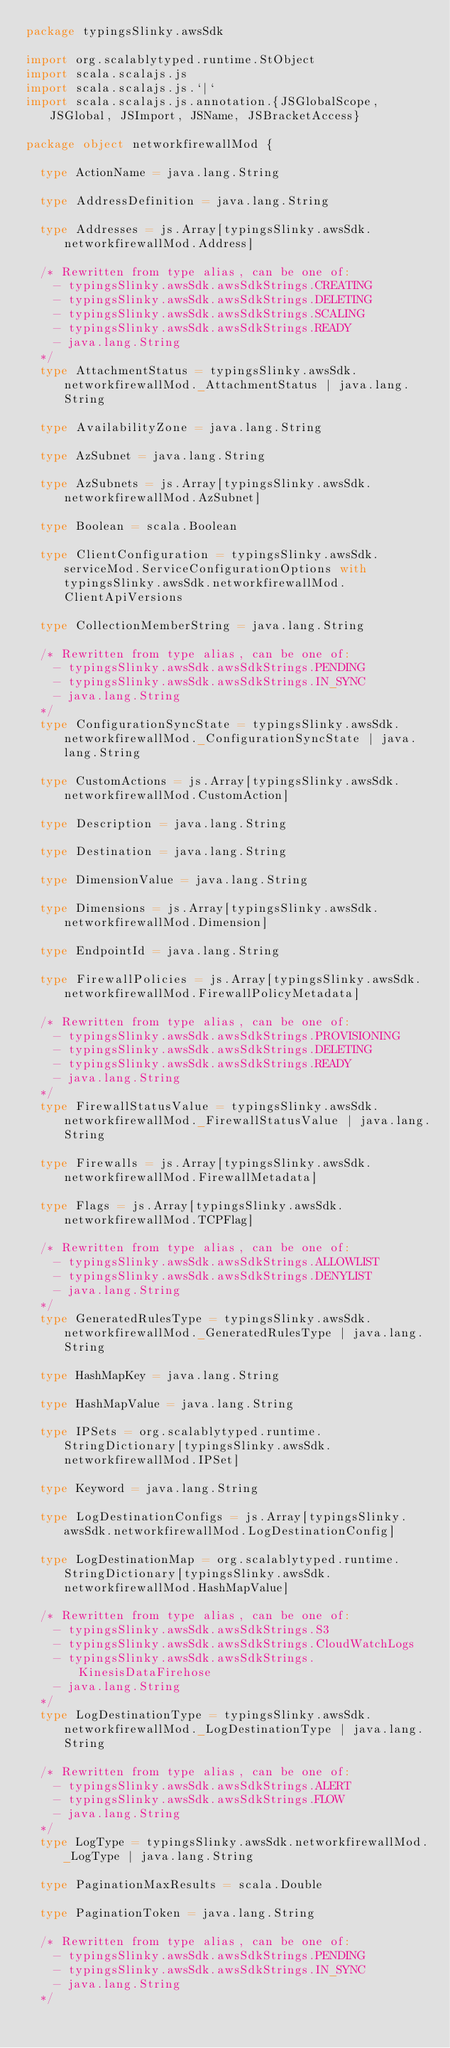Convert code to text. <code><loc_0><loc_0><loc_500><loc_500><_Scala_>package typingsSlinky.awsSdk

import org.scalablytyped.runtime.StObject
import scala.scalajs.js
import scala.scalajs.js.`|`
import scala.scalajs.js.annotation.{JSGlobalScope, JSGlobal, JSImport, JSName, JSBracketAccess}

package object networkfirewallMod {
  
  type ActionName = java.lang.String
  
  type AddressDefinition = java.lang.String
  
  type Addresses = js.Array[typingsSlinky.awsSdk.networkfirewallMod.Address]
  
  /* Rewritten from type alias, can be one of: 
    - typingsSlinky.awsSdk.awsSdkStrings.CREATING
    - typingsSlinky.awsSdk.awsSdkStrings.DELETING
    - typingsSlinky.awsSdk.awsSdkStrings.SCALING
    - typingsSlinky.awsSdk.awsSdkStrings.READY
    - java.lang.String
  */
  type AttachmentStatus = typingsSlinky.awsSdk.networkfirewallMod._AttachmentStatus | java.lang.String
  
  type AvailabilityZone = java.lang.String
  
  type AzSubnet = java.lang.String
  
  type AzSubnets = js.Array[typingsSlinky.awsSdk.networkfirewallMod.AzSubnet]
  
  type Boolean = scala.Boolean
  
  type ClientConfiguration = typingsSlinky.awsSdk.serviceMod.ServiceConfigurationOptions with typingsSlinky.awsSdk.networkfirewallMod.ClientApiVersions
  
  type CollectionMemberString = java.lang.String
  
  /* Rewritten from type alias, can be one of: 
    - typingsSlinky.awsSdk.awsSdkStrings.PENDING
    - typingsSlinky.awsSdk.awsSdkStrings.IN_SYNC
    - java.lang.String
  */
  type ConfigurationSyncState = typingsSlinky.awsSdk.networkfirewallMod._ConfigurationSyncState | java.lang.String
  
  type CustomActions = js.Array[typingsSlinky.awsSdk.networkfirewallMod.CustomAction]
  
  type Description = java.lang.String
  
  type Destination = java.lang.String
  
  type DimensionValue = java.lang.String
  
  type Dimensions = js.Array[typingsSlinky.awsSdk.networkfirewallMod.Dimension]
  
  type EndpointId = java.lang.String
  
  type FirewallPolicies = js.Array[typingsSlinky.awsSdk.networkfirewallMod.FirewallPolicyMetadata]
  
  /* Rewritten from type alias, can be one of: 
    - typingsSlinky.awsSdk.awsSdkStrings.PROVISIONING
    - typingsSlinky.awsSdk.awsSdkStrings.DELETING
    - typingsSlinky.awsSdk.awsSdkStrings.READY
    - java.lang.String
  */
  type FirewallStatusValue = typingsSlinky.awsSdk.networkfirewallMod._FirewallStatusValue | java.lang.String
  
  type Firewalls = js.Array[typingsSlinky.awsSdk.networkfirewallMod.FirewallMetadata]
  
  type Flags = js.Array[typingsSlinky.awsSdk.networkfirewallMod.TCPFlag]
  
  /* Rewritten from type alias, can be one of: 
    - typingsSlinky.awsSdk.awsSdkStrings.ALLOWLIST
    - typingsSlinky.awsSdk.awsSdkStrings.DENYLIST
    - java.lang.String
  */
  type GeneratedRulesType = typingsSlinky.awsSdk.networkfirewallMod._GeneratedRulesType | java.lang.String
  
  type HashMapKey = java.lang.String
  
  type HashMapValue = java.lang.String
  
  type IPSets = org.scalablytyped.runtime.StringDictionary[typingsSlinky.awsSdk.networkfirewallMod.IPSet]
  
  type Keyword = java.lang.String
  
  type LogDestinationConfigs = js.Array[typingsSlinky.awsSdk.networkfirewallMod.LogDestinationConfig]
  
  type LogDestinationMap = org.scalablytyped.runtime.StringDictionary[typingsSlinky.awsSdk.networkfirewallMod.HashMapValue]
  
  /* Rewritten from type alias, can be one of: 
    - typingsSlinky.awsSdk.awsSdkStrings.S3
    - typingsSlinky.awsSdk.awsSdkStrings.CloudWatchLogs
    - typingsSlinky.awsSdk.awsSdkStrings.KinesisDataFirehose
    - java.lang.String
  */
  type LogDestinationType = typingsSlinky.awsSdk.networkfirewallMod._LogDestinationType | java.lang.String
  
  /* Rewritten from type alias, can be one of: 
    - typingsSlinky.awsSdk.awsSdkStrings.ALERT
    - typingsSlinky.awsSdk.awsSdkStrings.FLOW
    - java.lang.String
  */
  type LogType = typingsSlinky.awsSdk.networkfirewallMod._LogType | java.lang.String
  
  type PaginationMaxResults = scala.Double
  
  type PaginationToken = java.lang.String
  
  /* Rewritten from type alias, can be one of: 
    - typingsSlinky.awsSdk.awsSdkStrings.PENDING
    - typingsSlinky.awsSdk.awsSdkStrings.IN_SYNC
    - java.lang.String
  */</code> 